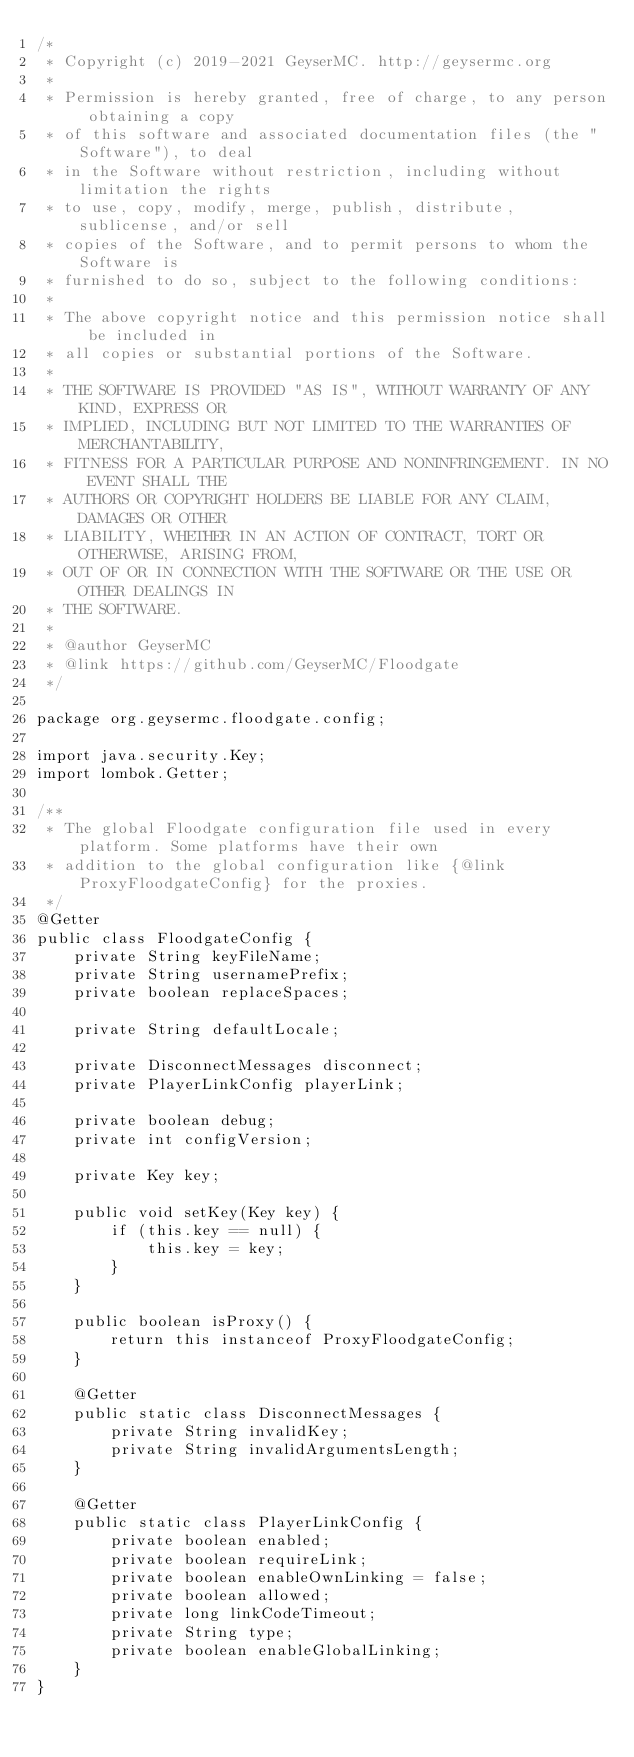Convert code to text. <code><loc_0><loc_0><loc_500><loc_500><_Java_>/*
 * Copyright (c) 2019-2021 GeyserMC. http://geysermc.org
 *
 * Permission is hereby granted, free of charge, to any person obtaining a copy
 * of this software and associated documentation files (the "Software"), to deal
 * in the Software without restriction, including without limitation the rights
 * to use, copy, modify, merge, publish, distribute, sublicense, and/or sell
 * copies of the Software, and to permit persons to whom the Software is
 * furnished to do so, subject to the following conditions:
 *
 * The above copyright notice and this permission notice shall be included in
 * all copies or substantial portions of the Software.
 *
 * THE SOFTWARE IS PROVIDED "AS IS", WITHOUT WARRANTY OF ANY KIND, EXPRESS OR
 * IMPLIED, INCLUDING BUT NOT LIMITED TO THE WARRANTIES OF MERCHANTABILITY,
 * FITNESS FOR A PARTICULAR PURPOSE AND NONINFRINGEMENT. IN NO EVENT SHALL THE
 * AUTHORS OR COPYRIGHT HOLDERS BE LIABLE FOR ANY CLAIM, DAMAGES OR OTHER
 * LIABILITY, WHETHER IN AN ACTION OF CONTRACT, TORT OR OTHERWISE, ARISING FROM,
 * OUT OF OR IN CONNECTION WITH THE SOFTWARE OR THE USE OR OTHER DEALINGS IN
 * THE SOFTWARE.
 *
 * @author GeyserMC
 * @link https://github.com/GeyserMC/Floodgate
 */

package org.geysermc.floodgate.config;

import java.security.Key;
import lombok.Getter;

/**
 * The global Floodgate configuration file used in every platform. Some platforms have their own
 * addition to the global configuration like {@link ProxyFloodgateConfig} for the proxies.
 */
@Getter
public class FloodgateConfig {
    private String keyFileName;
    private String usernamePrefix;
    private boolean replaceSpaces;

    private String defaultLocale;

    private DisconnectMessages disconnect;
    private PlayerLinkConfig playerLink;

    private boolean debug;
    private int configVersion;

    private Key key;

    public void setKey(Key key) {
        if (this.key == null) {
            this.key = key;
        }
    }

    public boolean isProxy() {
        return this instanceof ProxyFloodgateConfig;
    }

    @Getter
    public static class DisconnectMessages {
        private String invalidKey;
        private String invalidArgumentsLength;
    }

    @Getter
    public static class PlayerLinkConfig {
        private boolean enabled;
        private boolean requireLink;
        private boolean enableOwnLinking = false;
        private boolean allowed;
        private long linkCodeTimeout;
        private String type;
        private boolean enableGlobalLinking;
    }
}
</code> 